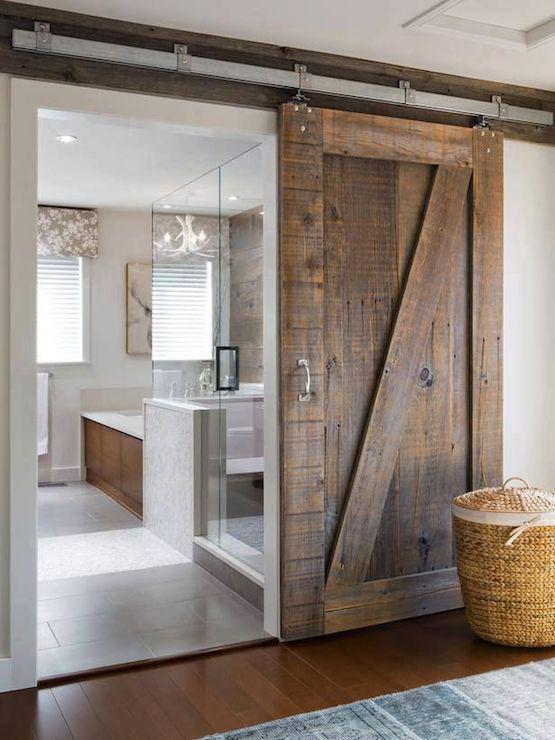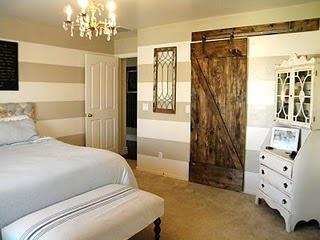The first image is the image on the left, the second image is the image on the right. For the images displayed, is the sentence "There is a white chair shown in one of the images." factually correct? Answer yes or no. No. The first image is the image on the left, the second image is the image on the right. For the images shown, is this caption "There is a bed in the image on the right." true? Answer yes or no. Yes. 